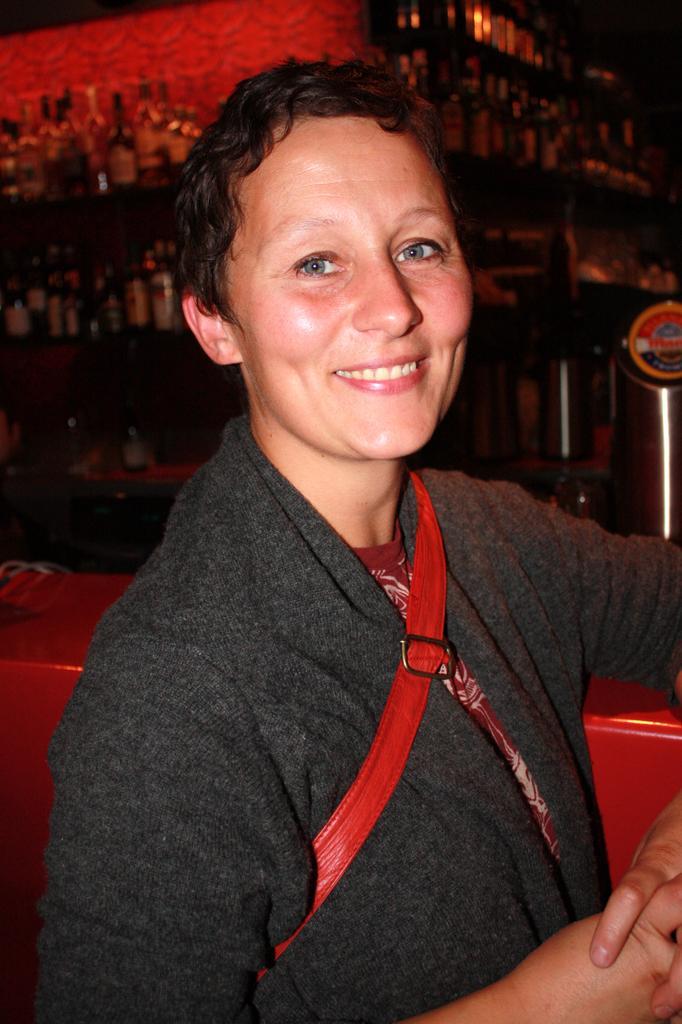Describe this image in one or two sentences. In the image we can see there is a person and behind there are wine bottles kept in the racks. Background of the image is little dark. 